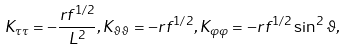Convert formula to latex. <formula><loc_0><loc_0><loc_500><loc_500>K _ { \tau \tau } = - \frac { r f ^ { 1 / 2 } } { L ^ { 2 } } , K _ { \vartheta \vartheta } = - r f ^ { 1 / 2 } , K _ { \varphi \varphi } = - r f ^ { 1 / 2 } \sin ^ { 2 } \vartheta ,</formula> 